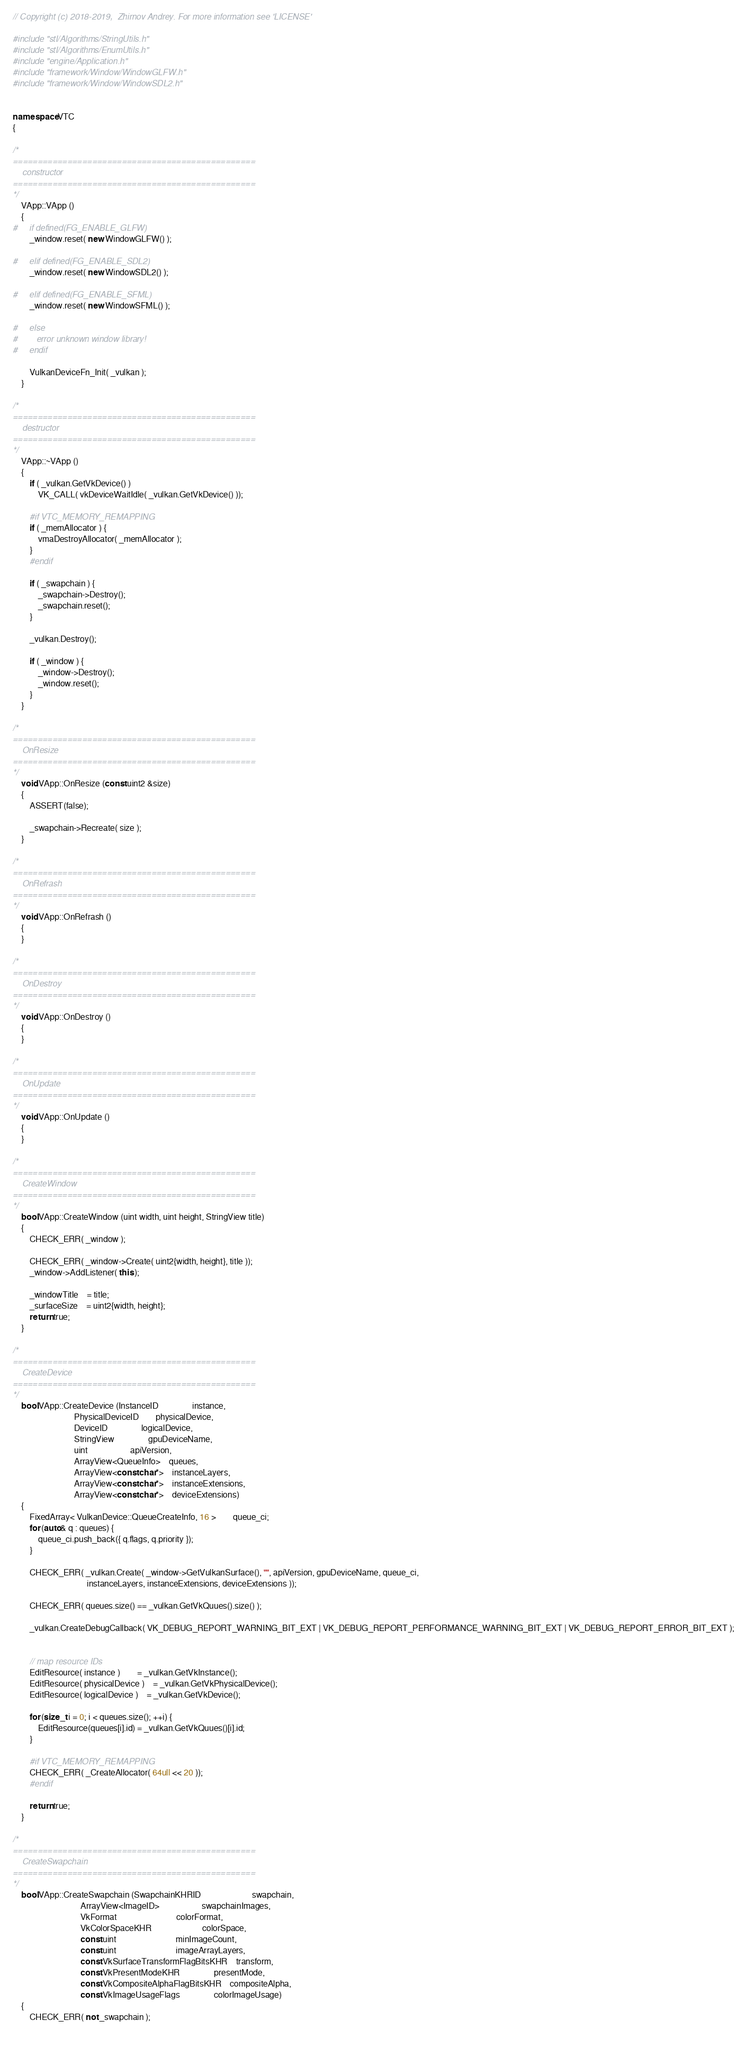Convert code to text. <code><loc_0><loc_0><loc_500><loc_500><_C++_>// Copyright (c) 2018-2019,  Zhirnov Andrey. For more information see 'LICENSE'

#include "stl/Algorithms/StringUtils.h"
#include "stl/Algorithms/EnumUtils.h"
#include "engine/Application.h"
#include "framework/Window/WindowGLFW.h"
#include "framework/Window/WindowSDL2.h"


namespace VTC
{

/*
=================================================
	constructor
=================================================
*/
	VApp::VApp ()
	{
#	 if defined(FG_ENABLE_GLFW)
		_window.reset( new WindowGLFW() );

#	 elif defined(FG_ENABLE_SDL2)
		_window.reset( new WindowSDL2() );
		
#	 elif defined(FG_ENABLE_SFML)
		_window.reset( new WindowSFML() );

#	 else
#		error unknown window library!
#	 endif

		VulkanDeviceFn_Init( _vulkan );
	}
	
/*
=================================================
	destructor
=================================================
*/
	VApp::~VApp ()
	{
		if ( _vulkan.GetVkDevice() )
			VK_CALL( vkDeviceWaitIdle( _vulkan.GetVkDevice() ));

		#if VTC_MEMORY_REMAPPING
		if ( _memAllocator ) {
			vmaDestroyAllocator( _memAllocator );
		}
		#endif

		if ( _swapchain ) {
			_swapchain->Destroy();
			_swapchain.reset();
		}

		_vulkan.Destroy();

		if ( _window ) {
			_window->Destroy();
			_window.reset();
		}
	}
	
/*
=================================================
	OnResize
=================================================
*/
	void VApp::OnResize (const uint2 &size)
	{
		ASSERT(false);

		_swapchain->Recreate( size );
	}
	
/*
=================================================
	OnRefrash
=================================================
*/
	void VApp::OnRefrash ()
	{
	}
	
/*
=================================================
	OnDestroy
=================================================
*/
	void VApp::OnDestroy ()
	{
	}
	
/*
=================================================
	OnUpdate
=================================================
*/
	void VApp::OnUpdate ()
	{
	}

/*
=================================================
	CreateWindow
=================================================
*/
	bool VApp::CreateWindow (uint width, uint height, StringView title)
	{
		CHECK_ERR( _window );

		CHECK_ERR( _window->Create( uint2{width, height}, title ));
		_window->AddListener( this );

		_windowTitle	= title;
		_surfaceSize	= uint2{width, height};
		return true;
	}
	
/*
=================================================
	CreateDevice
=================================================
*/
	bool VApp::CreateDevice (InstanceID				instance,
							 PhysicalDeviceID		physicalDevice,
							 DeviceID				logicalDevice,
							 StringView				gpuDeviceName,
							 uint					apiVersion,
							 ArrayView<QueueInfo>	queues,
							 ArrayView<const char*>	instanceLayers,
							 ArrayView<const char*>	instanceExtensions,
							 ArrayView<const char*>	deviceExtensions)
	{
		FixedArray< VulkanDevice::QueueCreateInfo, 16 >		queue_ci;
		for (auto& q : queues) {
			queue_ci.push_back({ q.flags, q.priority });
		}

		CHECK_ERR( _vulkan.Create( _window->GetVulkanSurface(), "", apiVersion, gpuDeviceName, queue_ci,
								   instanceLayers, instanceExtensions, deviceExtensions ));

		CHECK_ERR( queues.size() == _vulkan.GetVkQuues().size() );

		_vulkan.CreateDebugCallback( VK_DEBUG_REPORT_WARNING_BIT_EXT | VK_DEBUG_REPORT_PERFORMANCE_WARNING_BIT_EXT | VK_DEBUG_REPORT_ERROR_BIT_EXT );


		// map resource IDs
		EditResource( instance )		= _vulkan.GetVkInstance();
		EditResource( physicalDevice )	= _vulkan.GetVkPhysicalDevice();
		EditResource( logicalDevice )	= _vulkan.GetVkDevice();

		for (size_t i = 0; i < queues.size(); ++i) {
			EditResource(queues[i].id) = _vulkan.GetVkQuues()[i].id;
		}

		#if VTC_MEMORY_REMAPPING
		CHECK_ERR( _CreateAllocator( 64ull << 20 ));
		#endif

		return true;
	}

/*
=================================================
	CreateSwapchain
=================================================
*/
	bool VApp::CreateSwapchain (SwapchainKHRID						swapchain,
								ArrayView<ImageID>					swapchainImages,
								VkFormat							colorFormat,
								VkColorSpaceKHR						colorSpace,
								const uint							minImageCount,
								const uint							imageArrayLayers,
								const VkSurfaceTransformFlagBitsKHR	transform,
								const VkPresentModeKHR				presentMode,
								const VkCompositeAlphaFlagBitsKHR	compositeAlpha,
								const VkImageUsageFlags				colorImageUsage)
	{
		CHECK_ERR( not _swapchain );
		</code> 